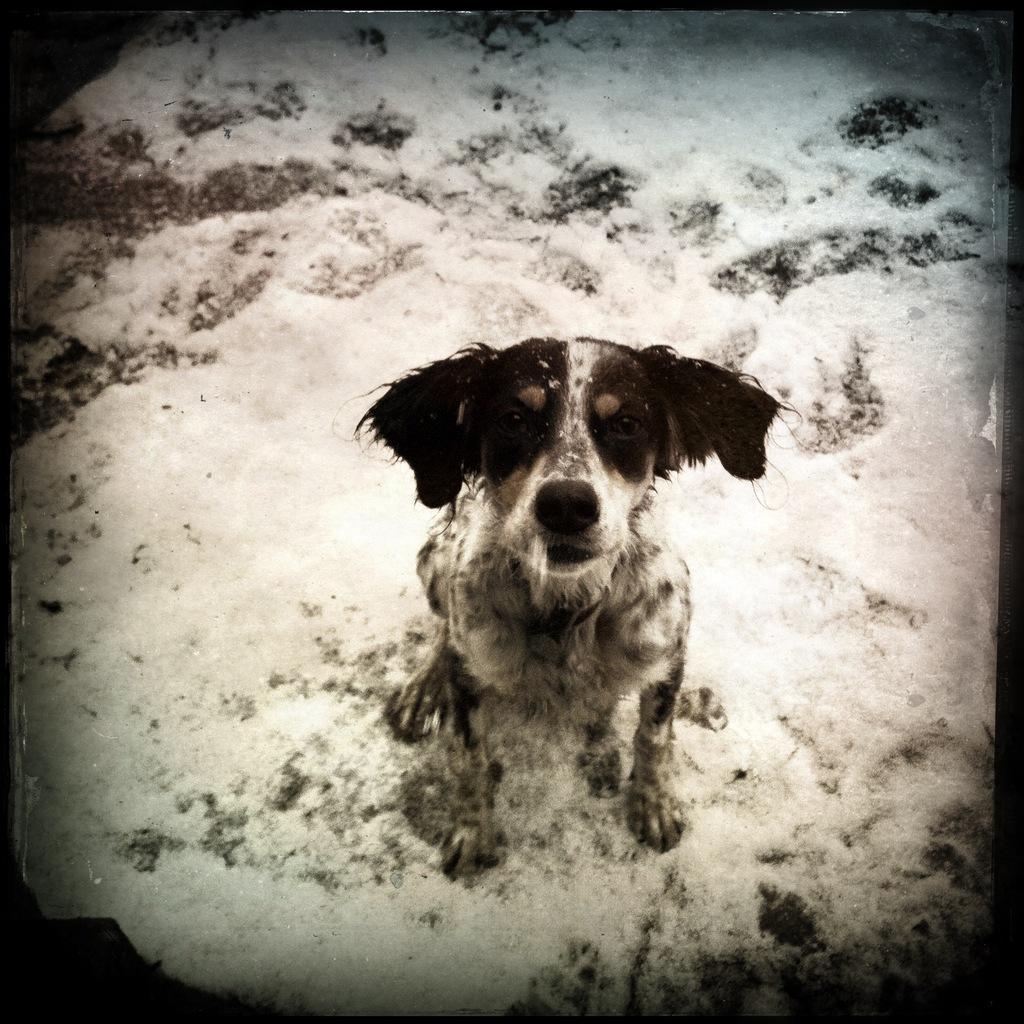Please provide a concise description of this image. This is an edited image. Here I can see a dog is sitting on the snow and looking at the picture. 